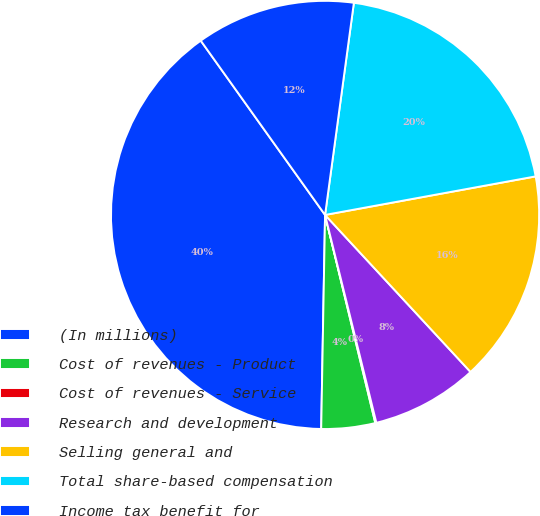Convert chart to OTSL. <chart><loc_0><loc_0><loc_500><loc_500><pie_chart><fcel>(In millions)<fcel>Cost of revenues - Product<fcel>Cost of revenues - Service<fcel>Research and development<fcel>Selling general and<fcel>Total share-based compensation<fcel>Income tax benefit for<nl><fcel>39.85%<fcel>4.06%<fcel>0.08%<fcel>8.04%<fcel>15.99%<fcel>19.97%<fcel>12.01%<nl></chart> 